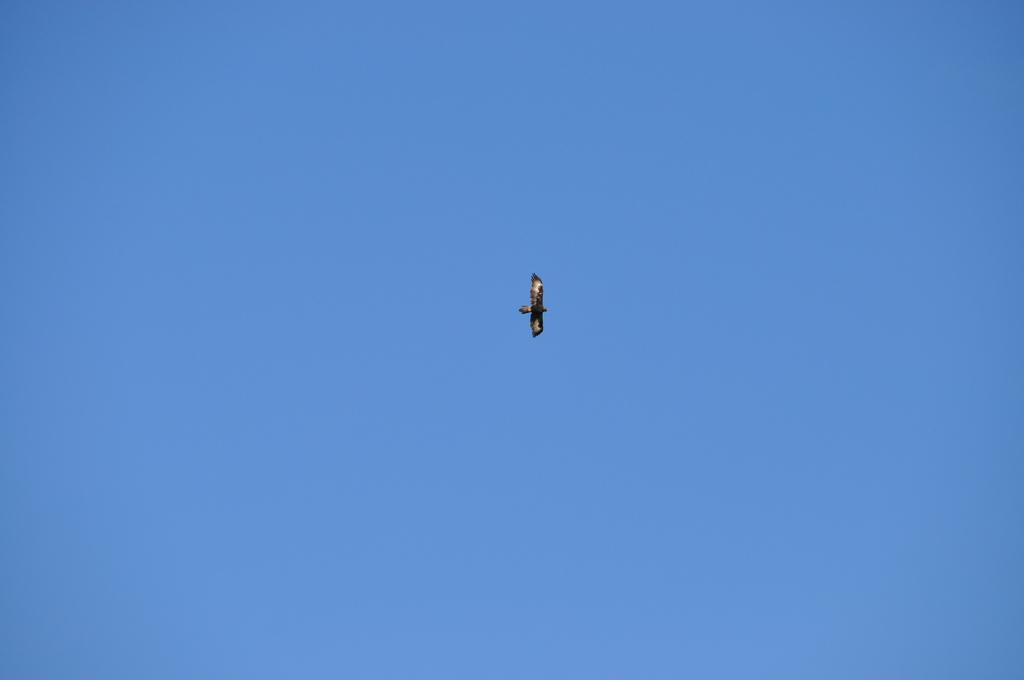What is the primary subject of the image? The image consists of the sky. Is there any other element present in the image besides the sky? Yes, there is a bird in the middle of the image. Can you describe the bird's position in the image? The bird is in the middle of the image. What can be observed about the bird's physical appearance? The bird has feathers. What type of company is located in the hall in the image? There is no hall or company present in the image; it only features the sky and a bird. 